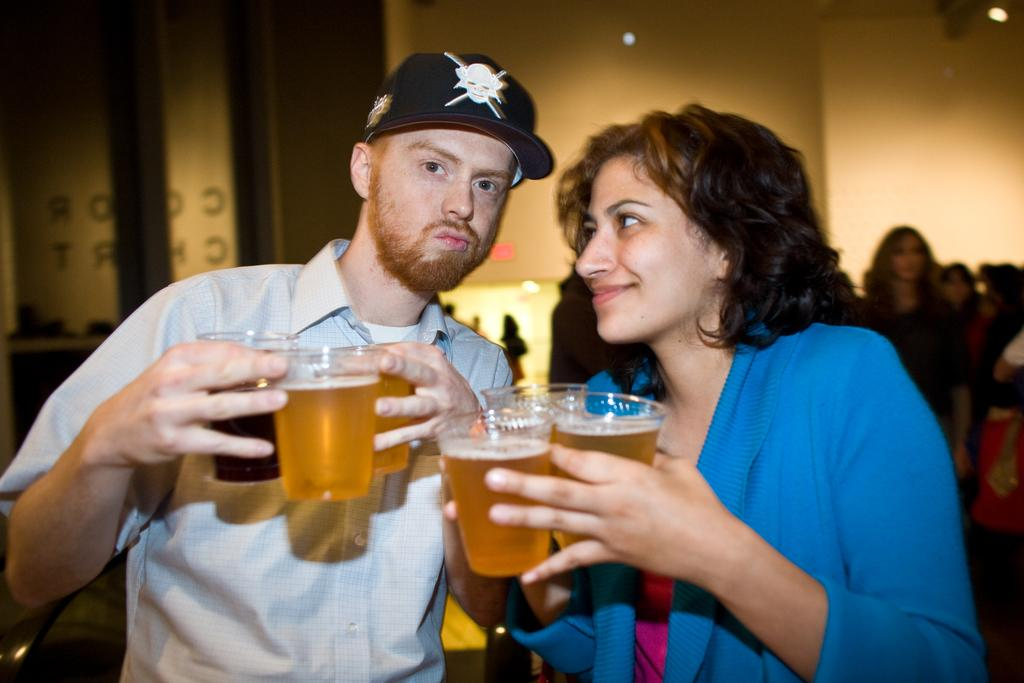Who is present in the image? There are women and a man standing in the image. What are the women and man holding in the image? The women and man are holding beer glasses. Can you describe the people in the background of the image? There are people standing in the background of the image. What type of pear is being used as a prop in the image? There is no pear present in the image. Can you tell me how many islands are visible in the background of the image? There are no islands visible in the image; it is a scene with people standing and holding beer glasses. 